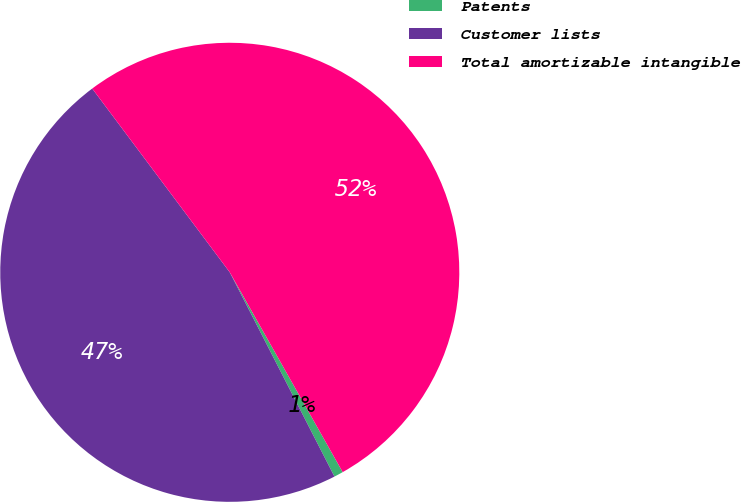Convert chart to OTSL. <chart><loc_0><loc_0><loc_500><loc_500><pie_chart><fcel>Patents<fcel>Customer lists<fcel>Total amortizable intangible<nl><fcel>0.65%<fcel>47.31%<fcel>52.04%<nl></chart> 